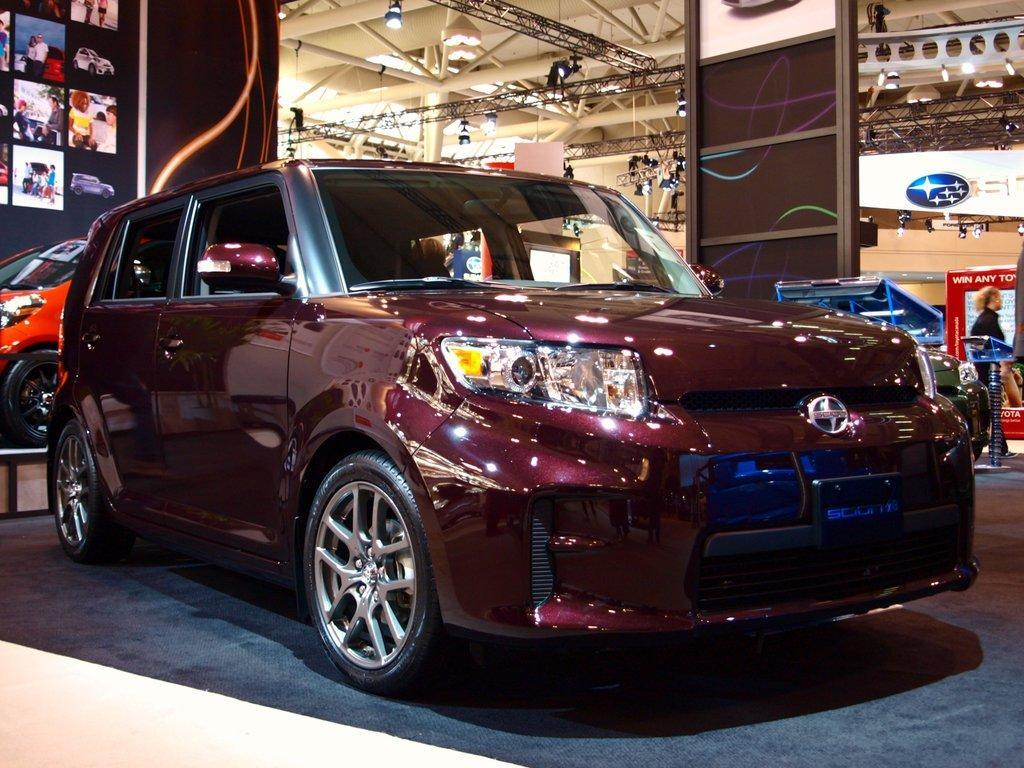Could you give a brief overview of what you see in this image? In this image we can see a few vehicles and people, there are some photographs, posters with some text and some other objects, at the top of the image we can some metal rods and lights. 